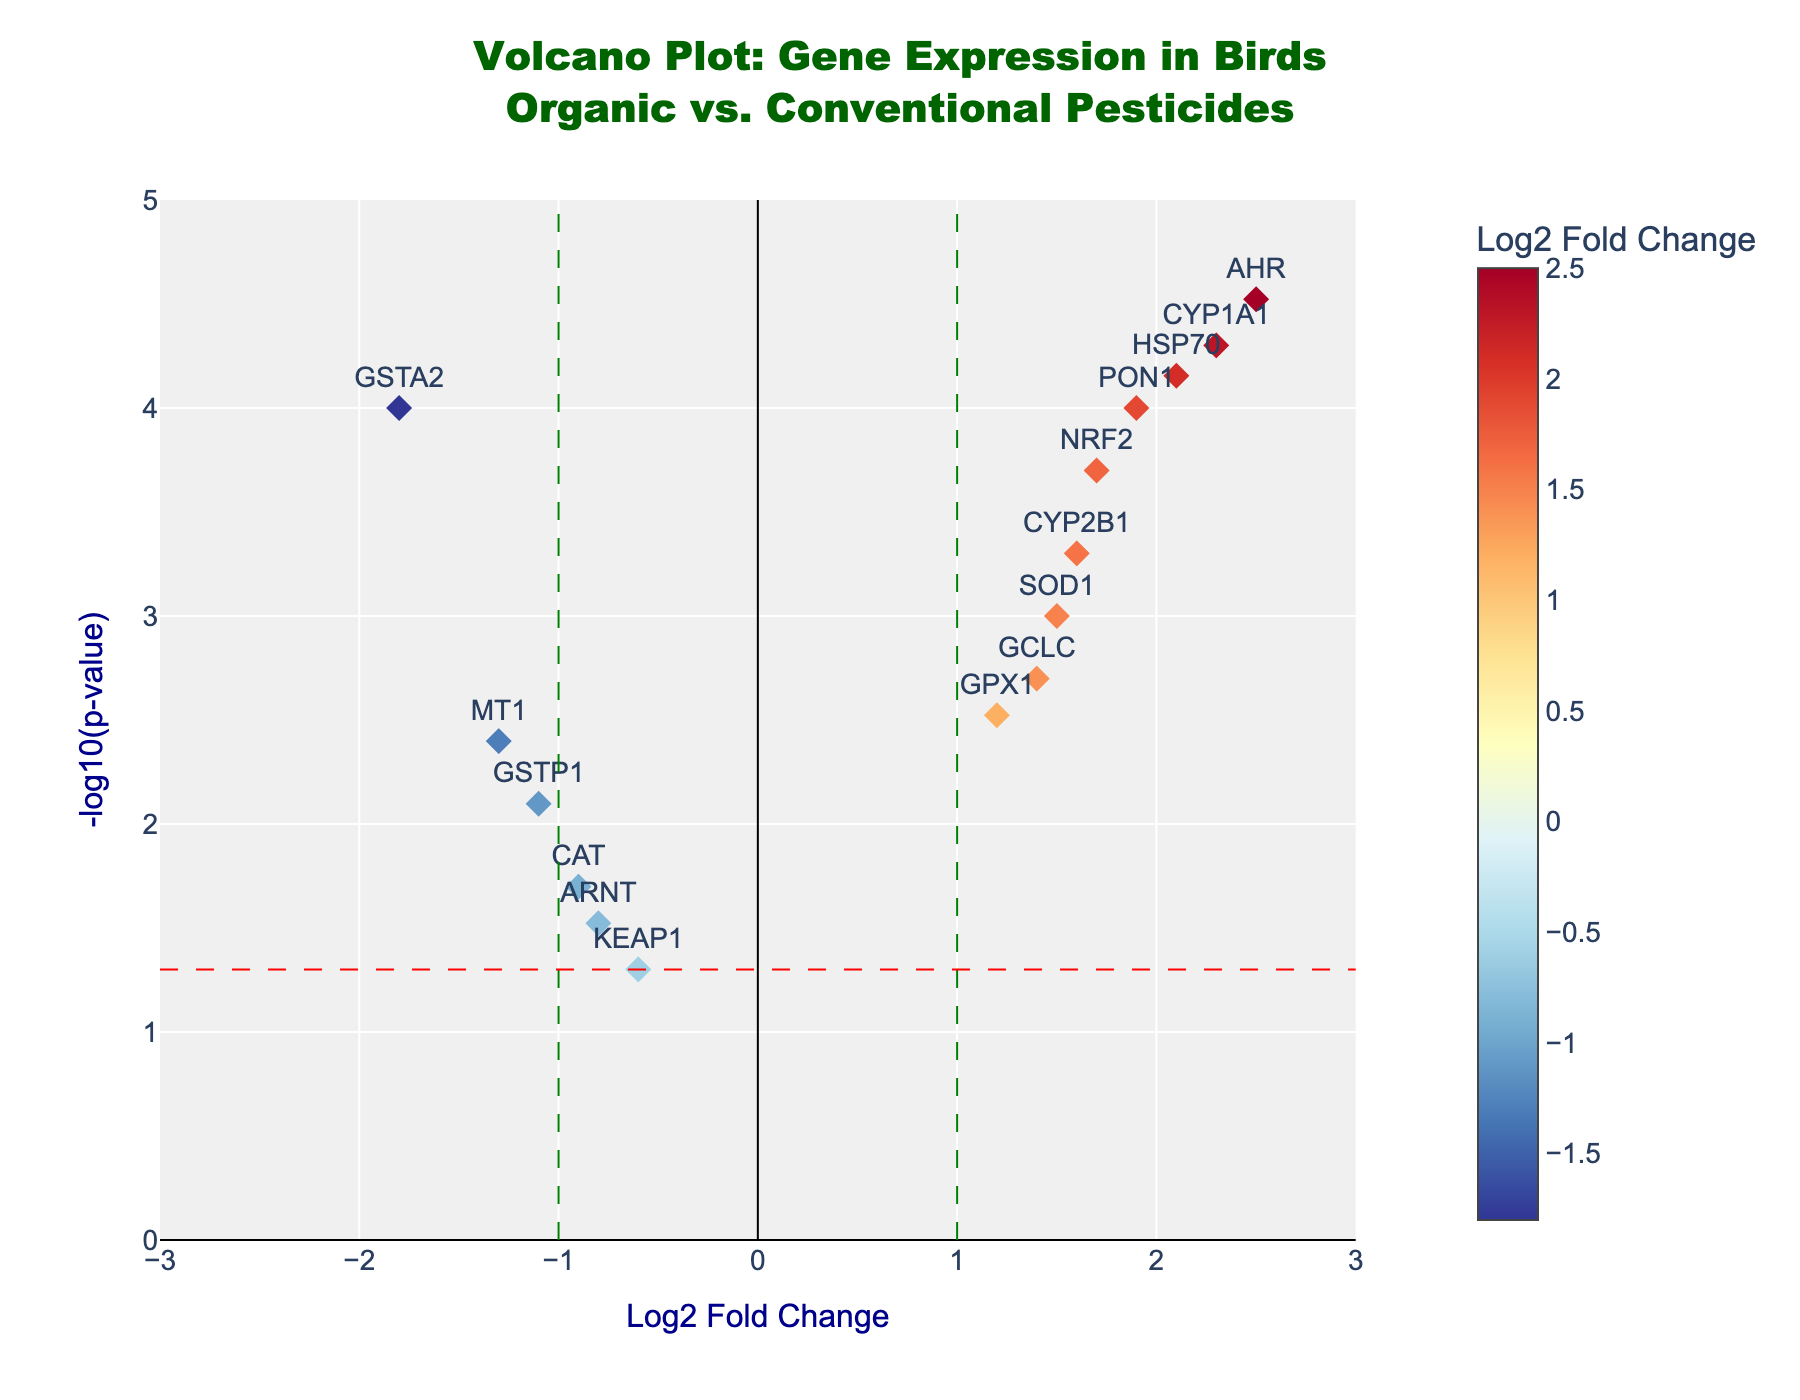what's the title of the plot? The title of the plot is usually located at the top center of the figure. Read the text displayed there to find the title.
Answer: Volcano Plot: Gene Expression in Birds<br>Organic vs. Conventional Pesticides what are the axes labels? The labels for the axes are found next to the axes themselves, usually at the ends closest to the origin.
Answer: Log2 Fold Change for the x-axis and -log10(p-value) for the y-axis how many data points are plotted? Count the number of visible markers (diamond shapes) representing the data points.
Answer: 15 which gene has the highest log2 fold change? Identify the gene with the highest x-axis value (log2 fold change).
Answer: AHR how many genes have a statistically significant p-value (p < 0.05)? Identify genes with y-axis values higher than the horizontal red dashed line (-log10(0.05)). Count these data points.
Answer: 11 which gene has the highest -log10(p-value)? Identify the gene with the highest y-axis value.
Answer: AHR how many genes have a log2 fold change less than -1? Identify data points on the left side of the vertical green dashed line at x = -1 and count them.
Answer: 2 which genes are above the significance threshold and have a positive log2 fold change? Identify data points above the red dashed line and to the right of the origin (x > 0).
Answer: CYP1A1, SOD1, GPX1, NRF2, HSP70, PON1, GCLC, CYP2B1 which gene has the smallest p-value? Identify the gene with the highest y-axis value since -log10(p-value) increases with smaller p-values.
Answer: AHR how many genes show downregulation (negative log2 fold change)? Identify markers to the left of the origin (x < 0) and count them.
Answer: 5 